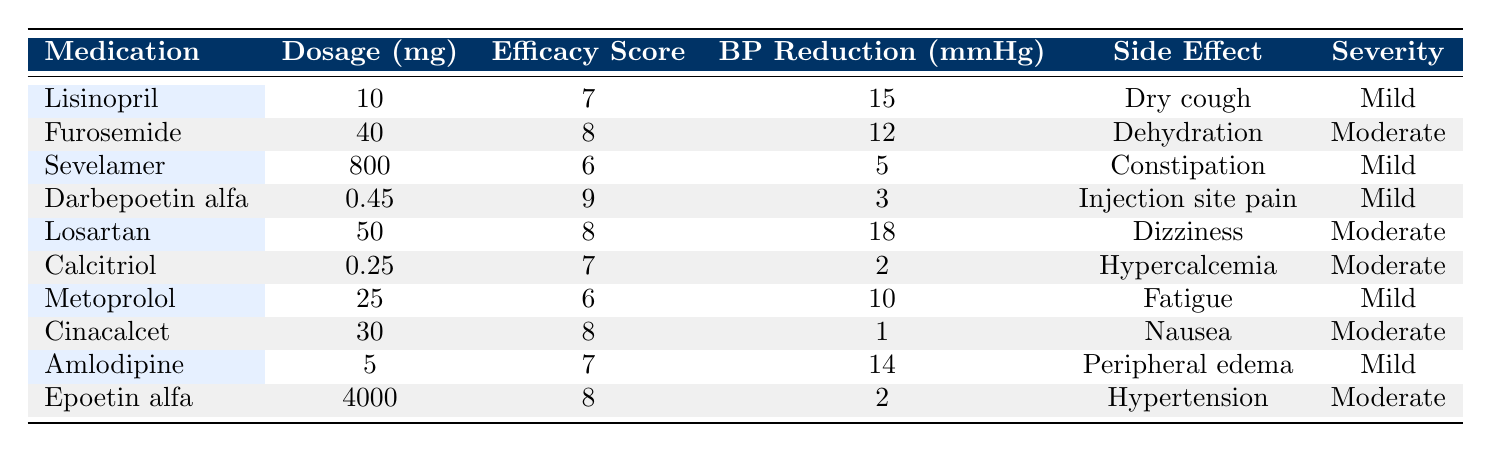What is the efficacy score of Lisinopril? The table lists Lisinopril in the first row with an efficacy score of 7.
Answer: 7 Which medication has the highest blood pressure reduction? By comparing the blood pressure reduction values in the table, Losartan has the highest value at 18 mmHg.
Answer: Losartan How many medications have a side effect classified as 'Moderate'? Checking each row, Furosemide, Losartan, Calcitriol, Cinacalcet, and Epoetin alfa are marked as having 'Moderate' severity, totaling five medications.
Answer: 5 What is the average efficacy score of the medications listed? The efficacy scores are: 7, 8, 6, 9, 8, 7, 6, 8, 7, 8. Summing these values gives 78. Dividing by the number of medications (10) results in an average of 78/10 = 7.8.
Answer: 7.8 Is there any medication that has a side effect of 'Dry cough'? The table shows that Lisinopril has 'Dry cough' listed as its side effect. Thus, the answer is yes.
Answer: Yes Which medication has the lowest creatinine level? By examining the creatinine levels in the table, Furosemide has the lowest value at 1.8 mg/dL.
Answer: Furosemide What is the difference between the highest and lowest efficacy scores? The highest efficacy score is 9 (Darbepoetin alfa), and the lowest is 6 (Sevelamer and Metoprolol). The difference is calculated as 9 - 6 = 3.
Answer: 3 How many male patients were treated with Cinacalcet or Losartan? The table shows that Cinacalcet and Losartan were prescribed to female and male patients respectively. Therefore, only Losartan is for a male patient (CKD005). Count is one.
Answer: 1 Does Epoetin alfa have a 'Mild' side effect? Epoetin alfa is listed with a 'Moderate' side effect in the table, indicating that it does not have a 'Mild' side effect.
Answer: No Which medication resulted in the least blood pressure reduction? By inspecting the blood pressure reduction values, Cinacalcet has the lowest reduction at 1 mmHg.
Answer: Cinacalcet 